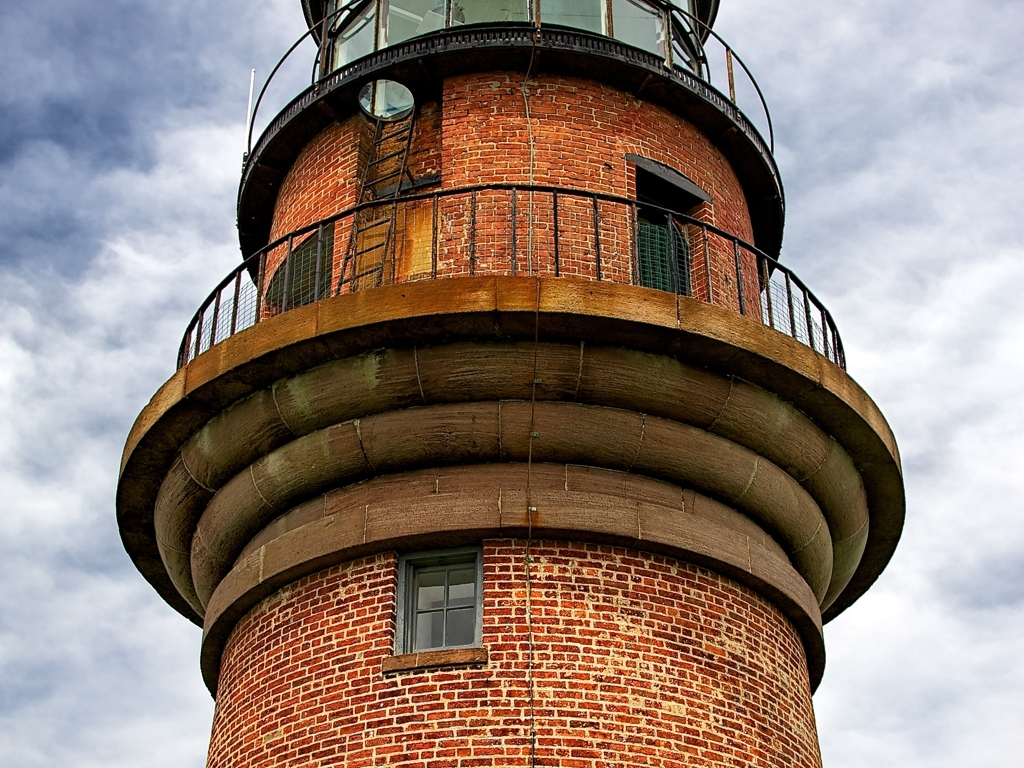Could you describe the weather and lighting conditions in this image? Certainly. The image depicts an overcast sky, with clouds scattering the light and providing a diffuse illumination. This kind of lighting minimizes harsh shadows, allowing the details of the lighthouse's brickwork and the structural features to be seen clearly. The lack of direct sunlight and the presence of moisture in the air suggests a fresh, possibly brisk weather condition that you might associate with coastal regions. 